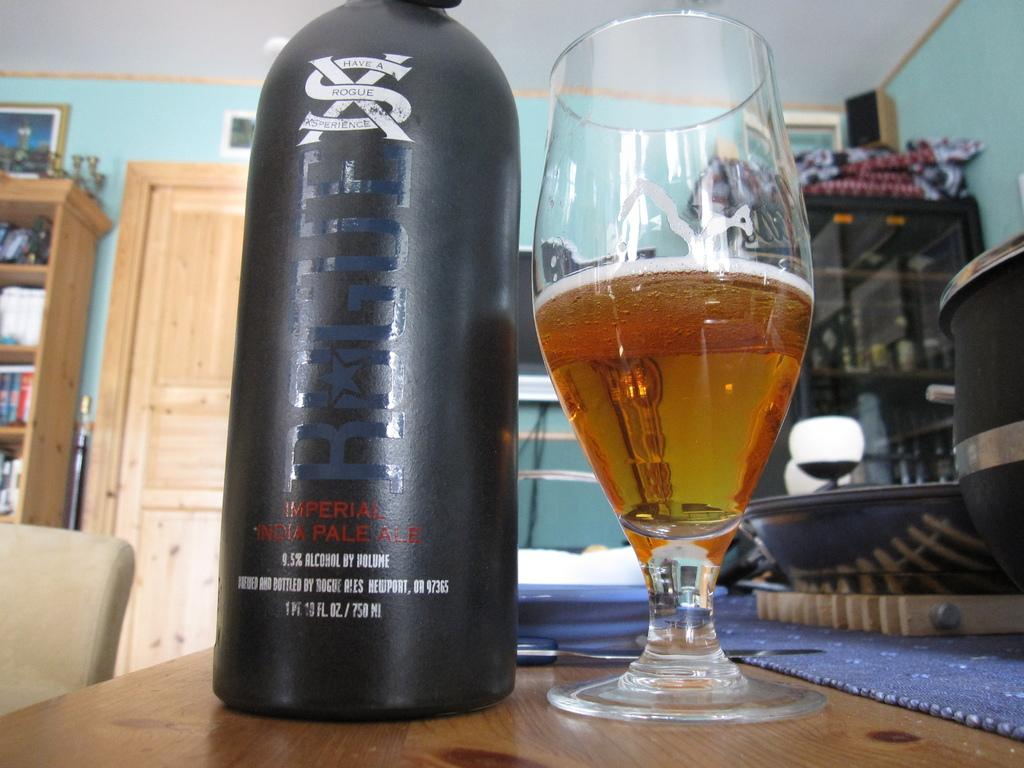<image>
Describe the image concisely. A bottle of Imperial India Pale Ale rests on a table next to a glass. 